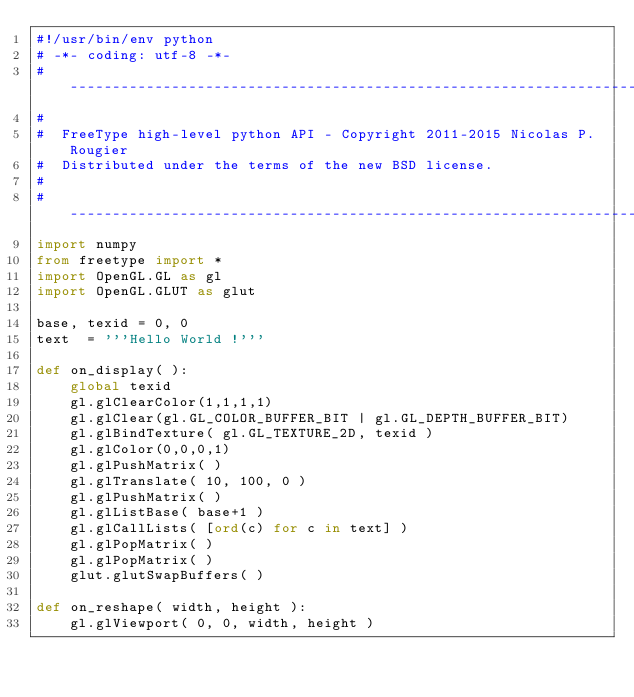<code> <loc_0><loc_0><loc_500><loc_500><_Python_>#!/usr/bin/env python
# -*- coding: utf-8 -*-
# -----------------------------------------------------------------------------
#
#  FreeType high-level python API - Copyright 2011-2015 Nicolas P. Rougier
#  Distributed under the terms of the new BSD license.
#
# -----------------------------------------------------------------------------
import numpy
from freetype import *
import OpenGL.GL as gl
import OpenGL.GLUT as glut

base, texid = 0, 0
text  = '''Hello World !'''

def on_display( ):
    global texid
    gl.glClearColor(1,1,1,1)
    gl.glClear(gl.GL_COLOR_BUFFER_BIT | gl.GL_DEPTH_BUFFER_BIT)
    gl.glBindTexture( gl.GL_TEXTURE_2D, texid )
    gl.glColor(0,0,0,1)
    gl.glPushMatrix( )
    gl.glTranslate( 10, 100, 0 )
    gl.glPushMatrix( )
    gl.glListBase( base+1 )
    gl.glCallLists( [ord(c) for c in text] )
    gl.glPopMatrix( )
    gl.glPopMatrix( )
    glut.glutSwapBuffers( )

def on_reshape( width, height ):
    gl.glViewport( 0, 0, width, height )</code> 